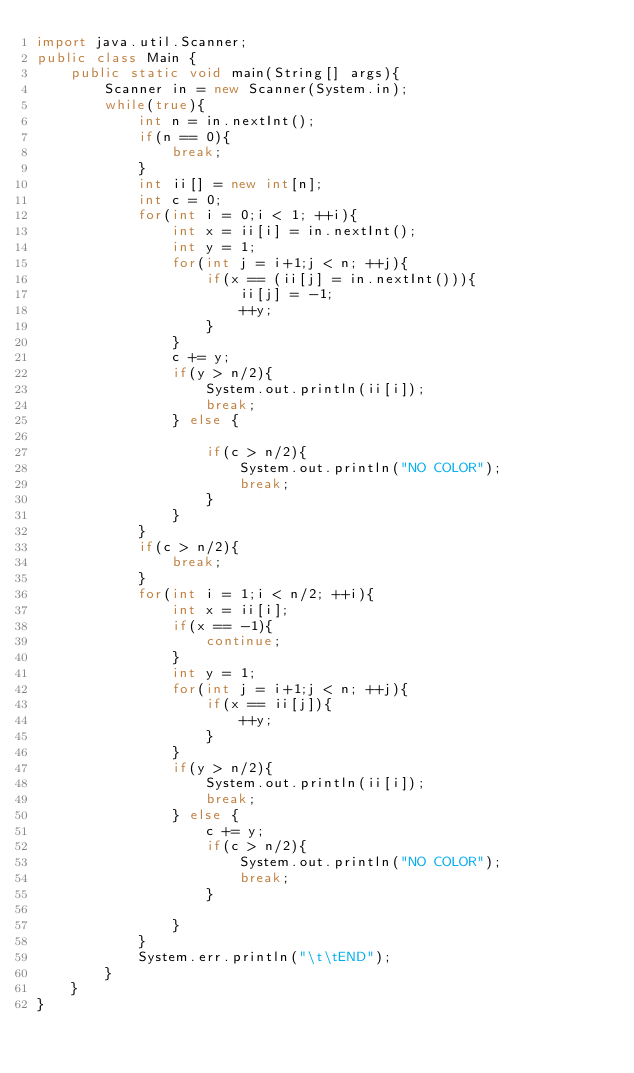Convert code to text. <code><loc_0><loc_0><loc_500><loc_500><_Java_>import java.util.Scanner;
public class Main {
	public static void main(String[] args){
		Scanner in = new Scanner(System.in);
		while(true){
			int n = in.nextInt();
			if(n == 0){
				break;
			}
			int ii[] = new int[n];
			int c = 0;
			for(int i = 0;i < 1; ++i){
				int x = ii[i] = in.nextInt();
				int y = 1;
				for(int j = i+1;j < n; ++j){
					if(x == (ii[j] = in.nextInt())){
						ii[j] = -1;
						++y;
					}
				}
				c += y;
				if(y > n/2){
					System.out.println(ii[i]);
					break;
				} else {

					if(c > n/2){
						System.out.println("NO COLOR");
						break;
					}
				}
			}
			if(c > n/2){
				break;
			}
			for(int i = 1;i < n/2; ++i){
				int x = ii[i];
				if(x == -1){
					continue;
				}
				int y = 1;
				for(int j = i+1;j < n; ++j){
					if(x == ii[j]){
						++y;
					}
				}
				if(y > n/2){
					System.out.println(ii[i]);
					break;
				} else {
					c += y;
					if(c > n/2){
						System.out.println("NO COLOR");
						break;
					}

				}
			}
			System.err.println("\t\tEND");
		}
	}
}</code> 